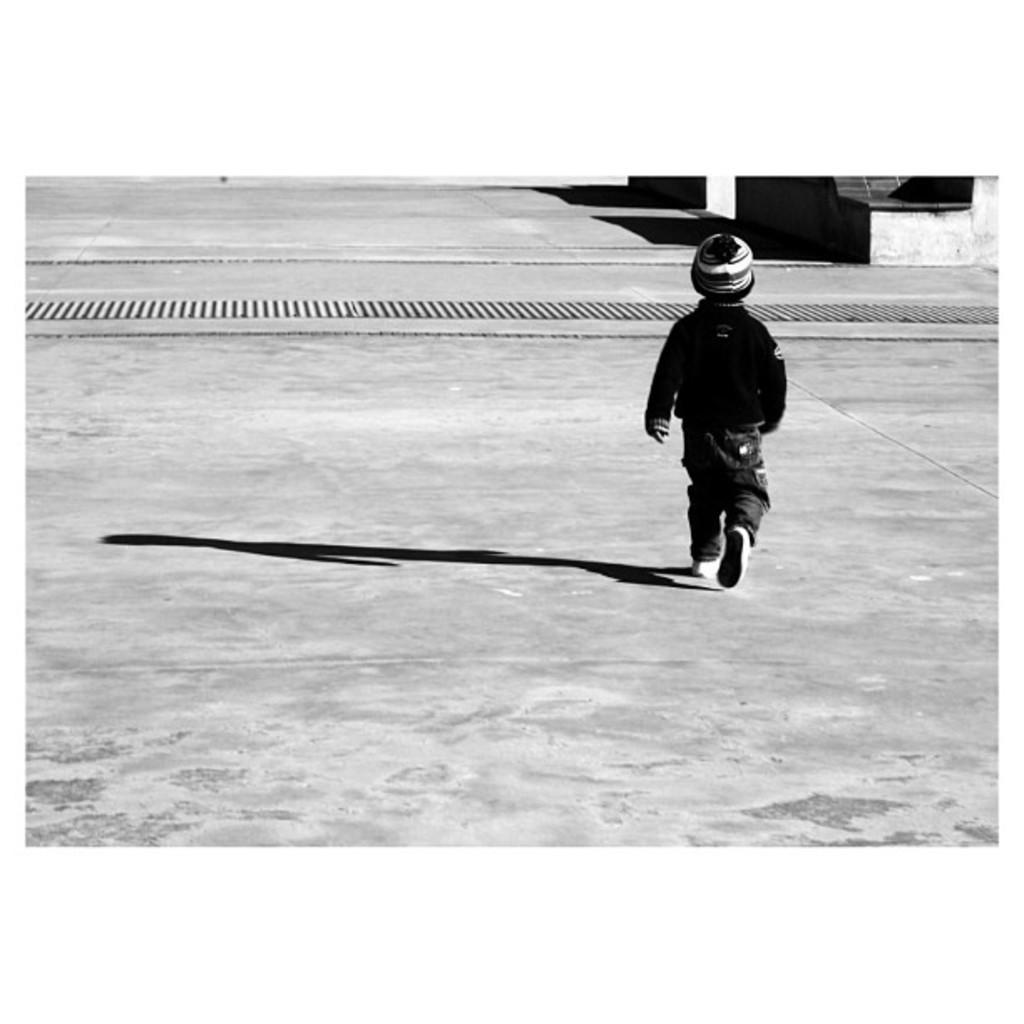Describe this image in one or two sentences. In this picture we can see a child wore a cap, walking and a shadow of this child on the ground and in the background we can see some objects. 